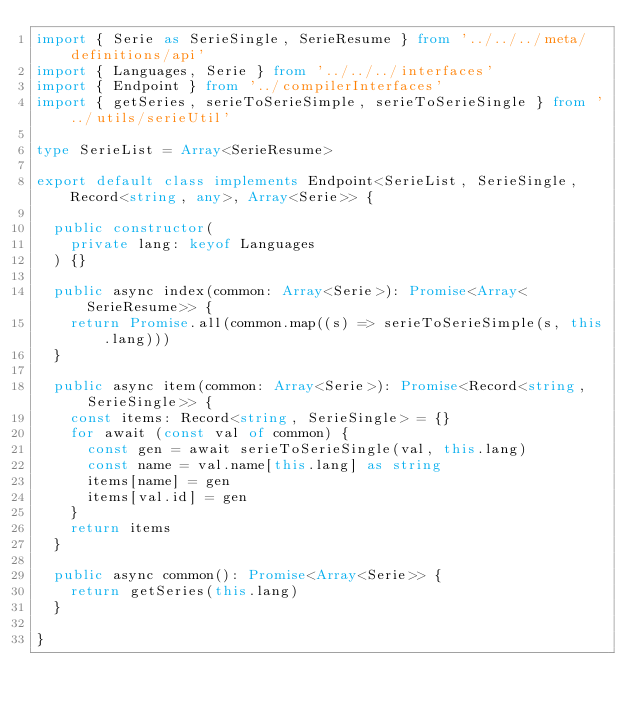<code> <loc_0><loc_0><loc_500><loc_500><_TypeScript_>import { Serie as SerieSingle, SerieResume } from '../../../meta/definitions/api'
import { Languages, Serie } from '../../../interfaces'
import { Endpoint } from '../compilerInterfaces'
import { getSeries, serieToSerieSimple, serieToSerieSingle } from '../utils/serieUtil'

type SerieList = Array<SerieResume>

export default class implements Endpoint<SerieList, SerieSingle, Record<string, any>, Array<Serie>> {

	public constructor(
		private lang: keyof Languages
	) {}

	public async index(common: Array<Serie>): Promise<Array<SerieResume>> {
		return Promise.all(common.map((s) => serieToSerieSimple(s, this.lang)))
	}

	public async item(common: Array<Serie>): Promise<Record<string, SerieSingle>> {
		const items: Record<string, SerieSingle> = {}
		for await (const val of common) {
			const gen = await serieToSerieSingle(val, this.lang)
			const name = val.name[this.lang] as string
			items[name] = gen
			items[val.id] = gen
		}
		return items
	}

	public async common(): Promise<Array<Serie>> {
		return getSeries(this.lang)
	}

}
</code> 